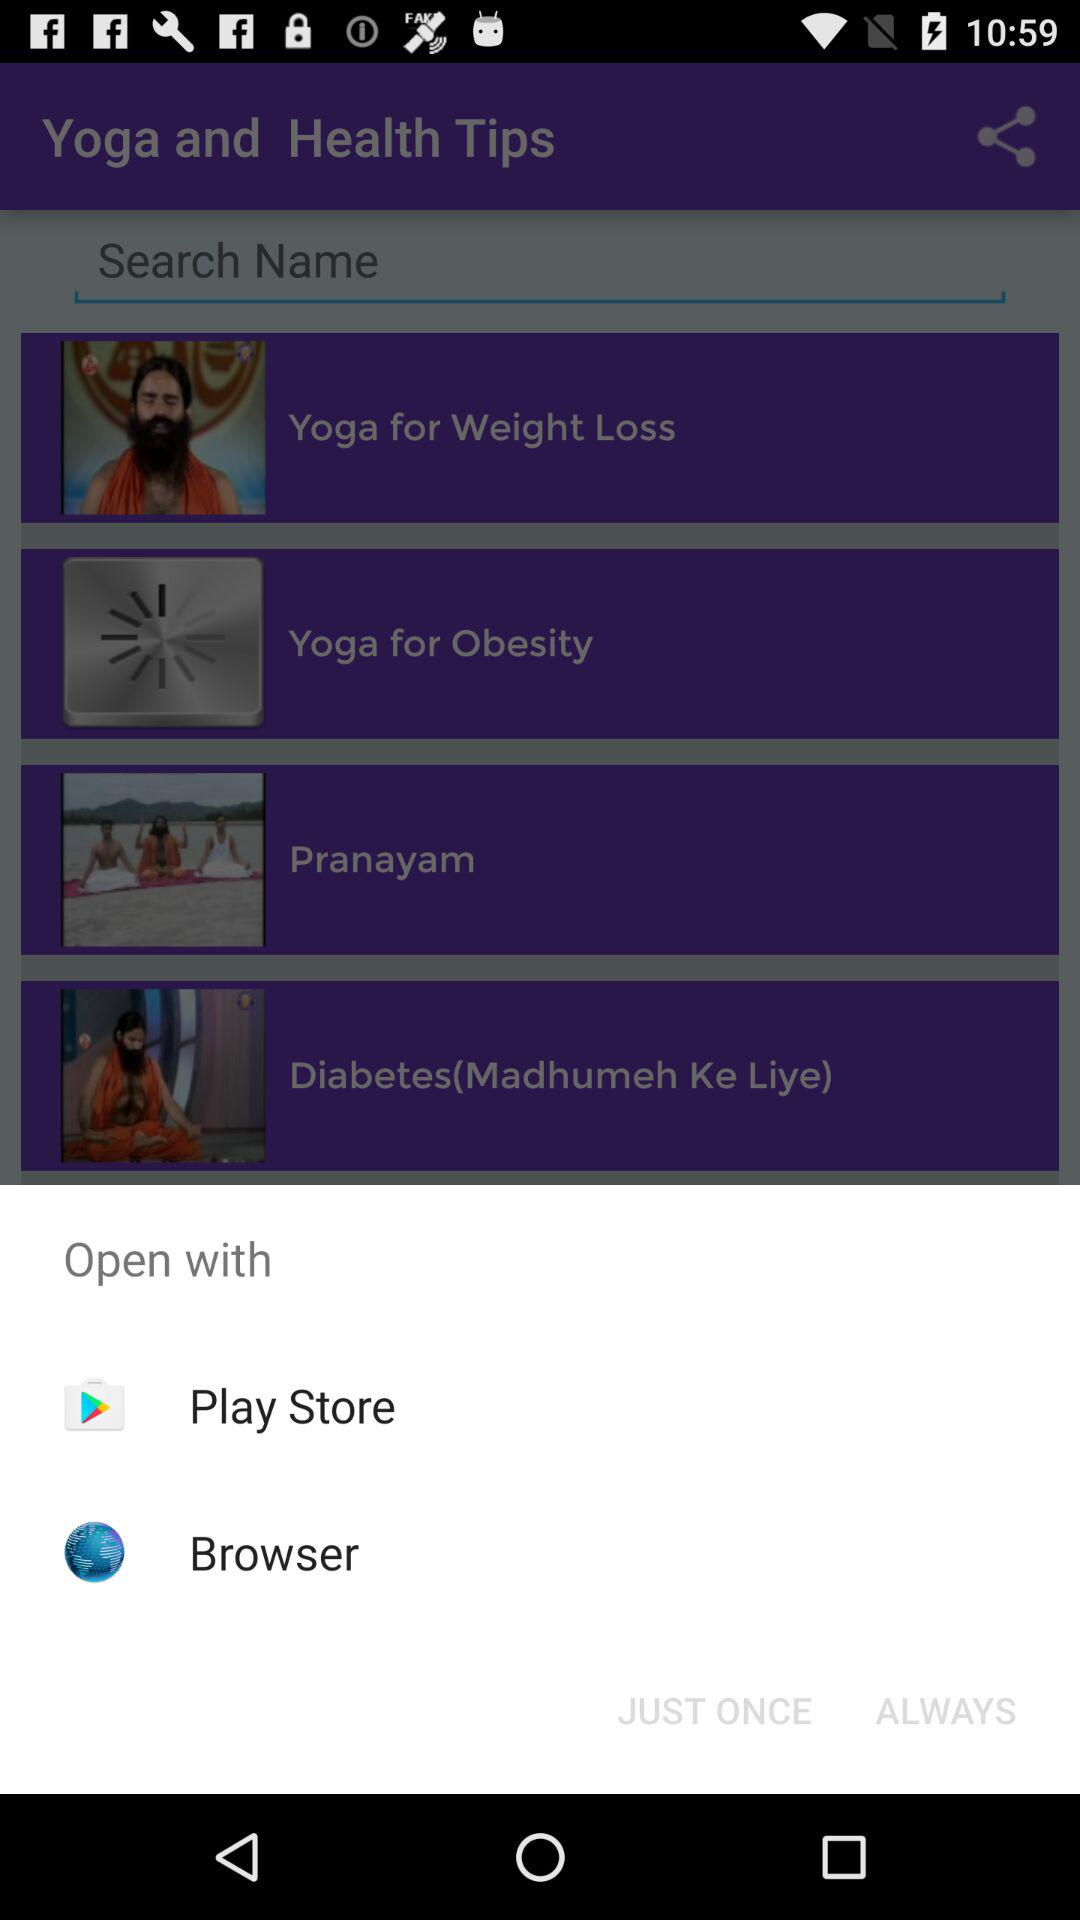How many items are there in the open with menu?
Answer the question using a single word or phrase. 2 